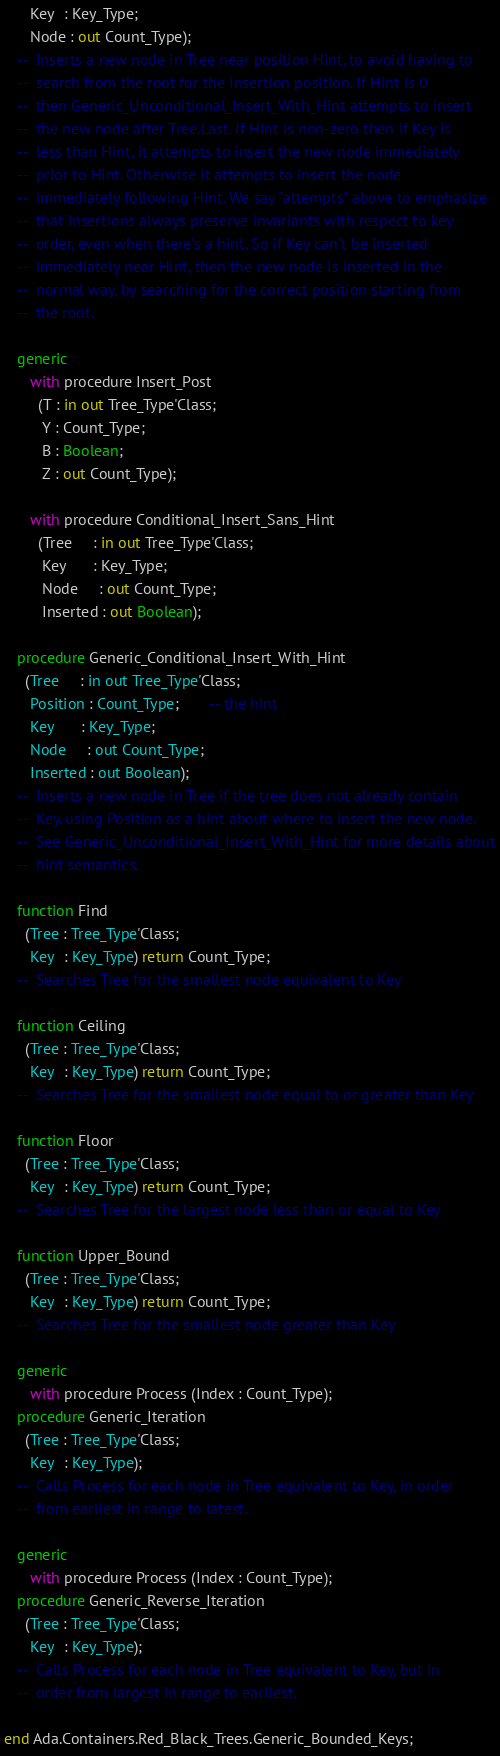Convert code to text. <code><loc_0><loc_0><loc_500><loc_500><_Ada_>      Key  : Key_Type;
      Node : out Count_Type);
   --  Inserts a new node in Tree near position Hint, to avoid having to
   --  search from the root for the insertion position. If Hint is 0
   --  then Generic_Unconditional_Insert_With_Hint attempts to insert
   --  the new node after Tree.Last. If Hint is non-zero then if Key is
   --  less than Hint, it attempts to insert the new node immediately
   --  prior to Hint. Otherwise it attempts to insert the node
   --  immediately following Hint. We say "attempts" above to emphasize
   --  that insertions always preserve invariants with respect to key
   --  order, even when there's a hint. So if Key can't be inserted
   --  immediately near Hint, then the new node is inserted in the
   --  normal way, by searching for the correct position starting from
   --  the root.

   generic
      with procedure Insert_Post
        (T : in out Tree_Type'Class;
         Y : Count_Type;
         B : Boolean;
         Z : out Count_Type);

      with procedure Conditional_Insert_Sans_Hint
        (Tree     : in out Tree_Type'Class;
         Key      : Key_Type;
         Node     : out Count_Type;
         Inserted : out Boolean);

   procedure Generic_Conditional_Insert_With_Hint
     (Tree     : in out Tree_Type'Class;
      Position : Count_Type;       -- the hint
      Key      : Key_Type;
      Node     : out Count_Type;
      Inserted : out Boolean);
   --  Inserts a new node in Tree if the tree does not already contain
   --  Key, using Position as a hint about where to insert the new node.
   --  See Generic_Unconditional_Insert_With_Hint for more details about
   --  hint semantics.

   function Find
     (Tree : Tree_Type'Class;
      Key  : Key_Type) return Count_Type;
   --  Searches Tree for the smallest node equivalent to Key

   function Ceiling
     (Tree : Tree_Type'Class;
      Key  : Key_Type) return Count_Type;
   --  Searches Tree for the smallest node equal to or greater than Key

   function Floor
     (Tree : Tree_Type'Class;
      Key  : Key_Type) return Count_Type;
   --  Searches Tree for the largest node less than or equal to Key

   function Upper_Bound
     (Tree : Tree_Type'Class;
      Key  : Key_Type) return Count_Type;
   --  Searches Tree for the smallest node greater than Key

   generic
      with procedure Process (Index : Count_Type);
   procedure Generic_Iteration
     (Tree : Tree_Type'Class;
      Key  : Key_Type);
   --  Calls Process for each node in Tree equivalent to Key, in order
   --  from earliest in range to latest.

   generic
      with procedure Process (Index : Count_Type);
   procedure Generic_Reverse_Iteration
     (Tree : Tree_Type'Class;
      Key  : Key_Type);
   --  Calls Process for each node in Tree equivalent to Key, but in
   --  order from largest in range to earliest.

end Ada.Containers.Red_Black_Trees.Generic_Bounded_Keys;
</code> 